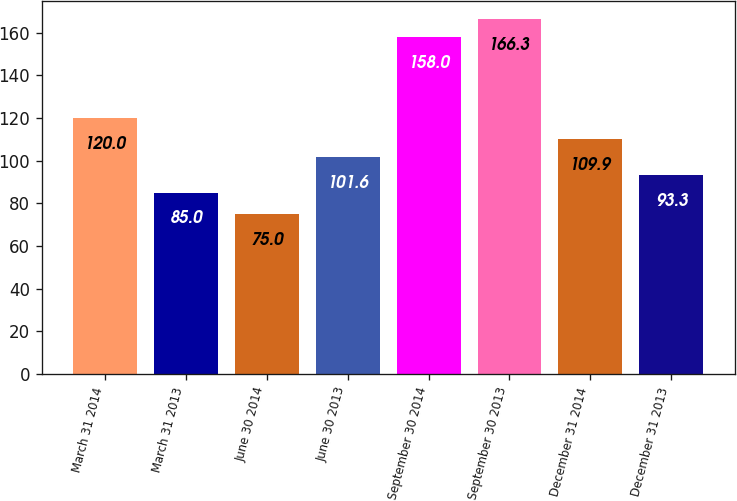<chart> <loc_0><loc_0><loc_500><loc_500><bar_chart><fcel>March 31 2014<fcel>March 31 2013<fcel>June 30 2014<fcel>June 30 2013<fcel>September 30 2014<fcel>September 30 2013<fcel>December 31 2014<fcel>December 31 2013<nl><fcel>120<fcel>85<fcel>75<fcel>101.6<fcel>158<fcel>166.3<fcel>109.9<fcel>93.3<nl></chart> 